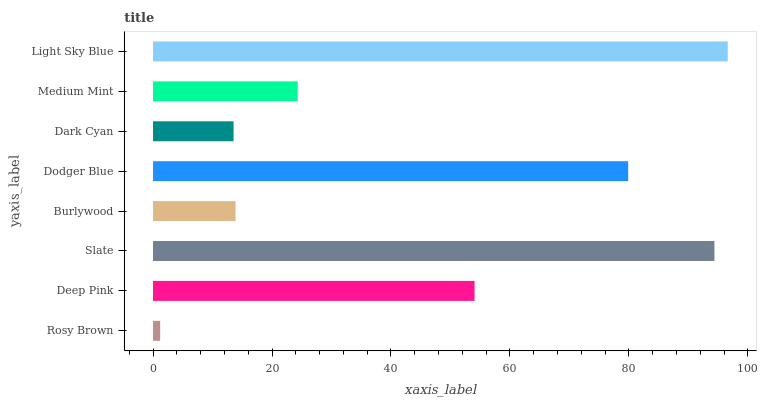Is Rosy Brown the minimum?
Answer yes or no. Yes. Is Light Sky Blue the maximum?
Answer yes or no. Yes. Is Deep Pink the minimum?
Answer yes or no. No. Is Deep Pink the maximum?
Answer yes or no. No. Is Deep Pink greater than Rosy Brown?
Answer yes or no. Yes. Is Rosy Brown less than Deep Pink?
Answer yes or no. Yes. Is Rosy Brown greater than Deep Pink?
Answer yes or no. No. Is Deep Pink less than Rosy Brown?
Answer yes or no. No. Is Deep Pink the high median?
Answer yes or no. Yes. Is Medium Mint the low median?
Answer yes or no. Yes. Is Dodger Blue the high median?
Answer yes or no. No. Is Slate the low median?
Answer yes or no. No. 